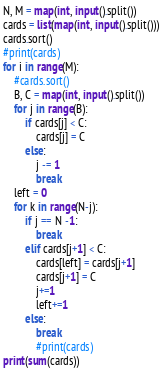<code> <loc_0><loc_0><loc_500><loc_500><_Python_>N, M = map(int, input().split())
cards = list(map(int, input().split()))
cards.sort()
#print(cards)
for i in range(M):
    #cards.sort()
    B, C = map(int, input().split())
    for j in range(B):
        if cards[j] < C:
            cards[j] = C
        else:
            j -= 1
            break
    left = 0
    for k in range(N-j):
        if j == N -1:
            break
        elif cards[j+1] < C:
            cards[left] = cards[j+1]
            cards[j+1] = C
            j+=1
            left+=1
        else:
            break
            #print(cards)
print(sum(cards))
</code> 